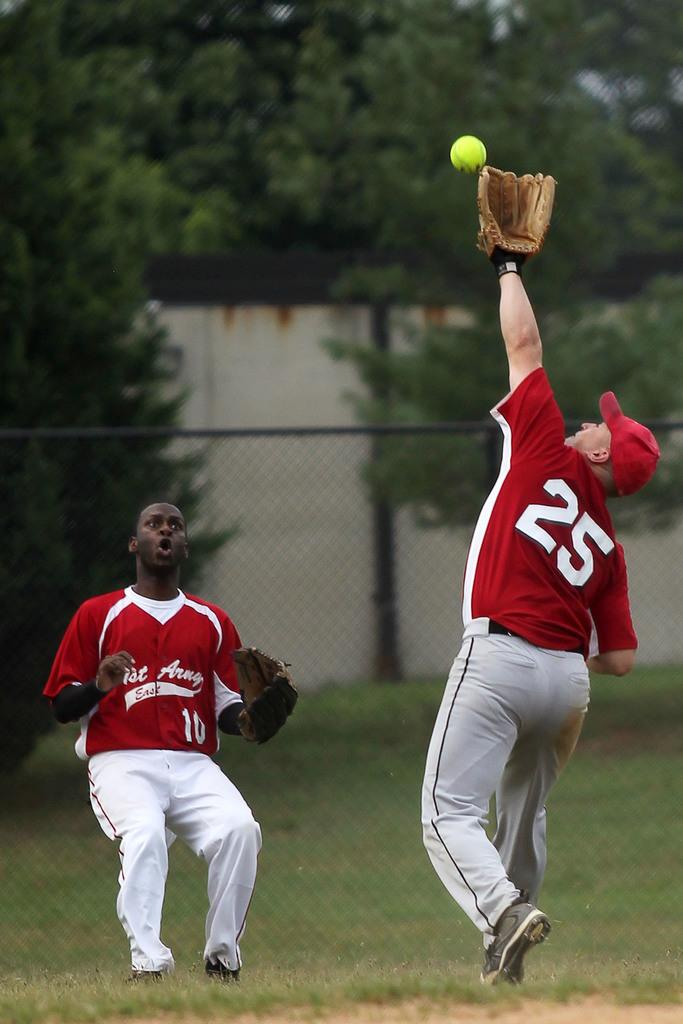What is the right player's jersey number?
Provide a short and direct response. 25. 